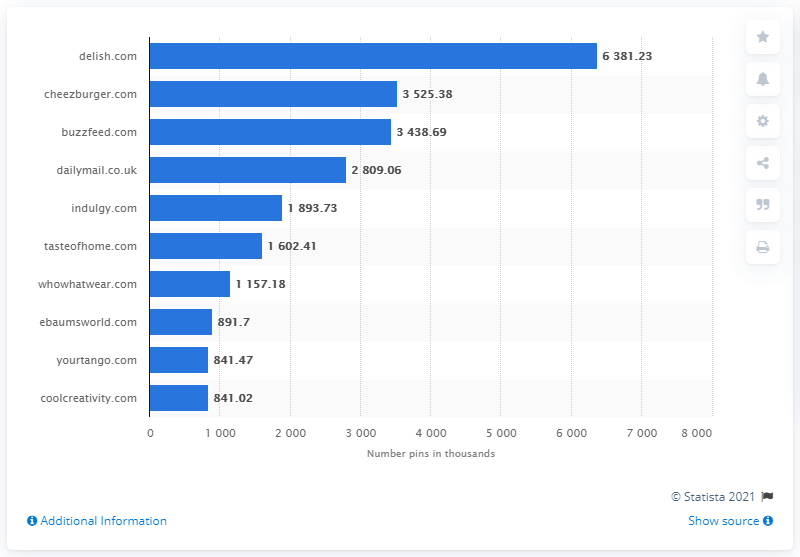List a handful of essential elements in this visual. During the month of April, Pinterest pinned a total of 6.38 million pieces of content from the website delish.com. 